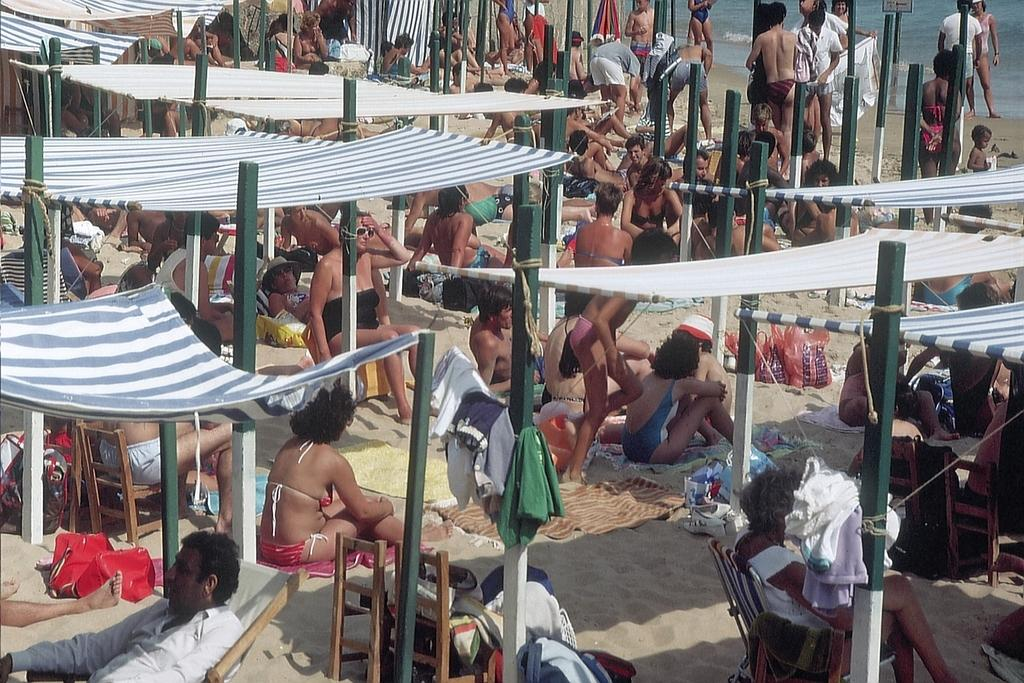How many people are in the image? There is a group of people in the image, but the exact number is not specified. What are the people doing in the image? Some people are sitting, while others are standing. What type of surface are the people on? The people are on sand. What structures can be seen in the image? There are tents in the image. What items are related to clothing in the image? Clothes are present in the image. What objects are used for support or stability in the image? Poles are visible in the image. What can be seen in the background of the image? There is water in the background of the image. Can you see a kitty playing with a hammer in the image? No, there is no kitty or hammer present in the image. What type of monkey can be seen swinging from the poles in the image? There are no monkeys present in the image; only people, tents, and poles can be seen. 